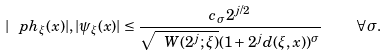<formula> <loc_0><loc_0><loc_500><loc_500>| \ p h _ { \xi } ( x ) | , | \psi _ { \xi } ( x ) | \leq \frac { c _ { \sigma } 2 ^ { j / 2 } } { \sqrt { \ W ( 2 ^ { j } ; \xi ) } ( 1 + 2 ^ { j } d ( \xi , x ) ) ^ { \sigma } } \quad \forall \sigma .</formula> 